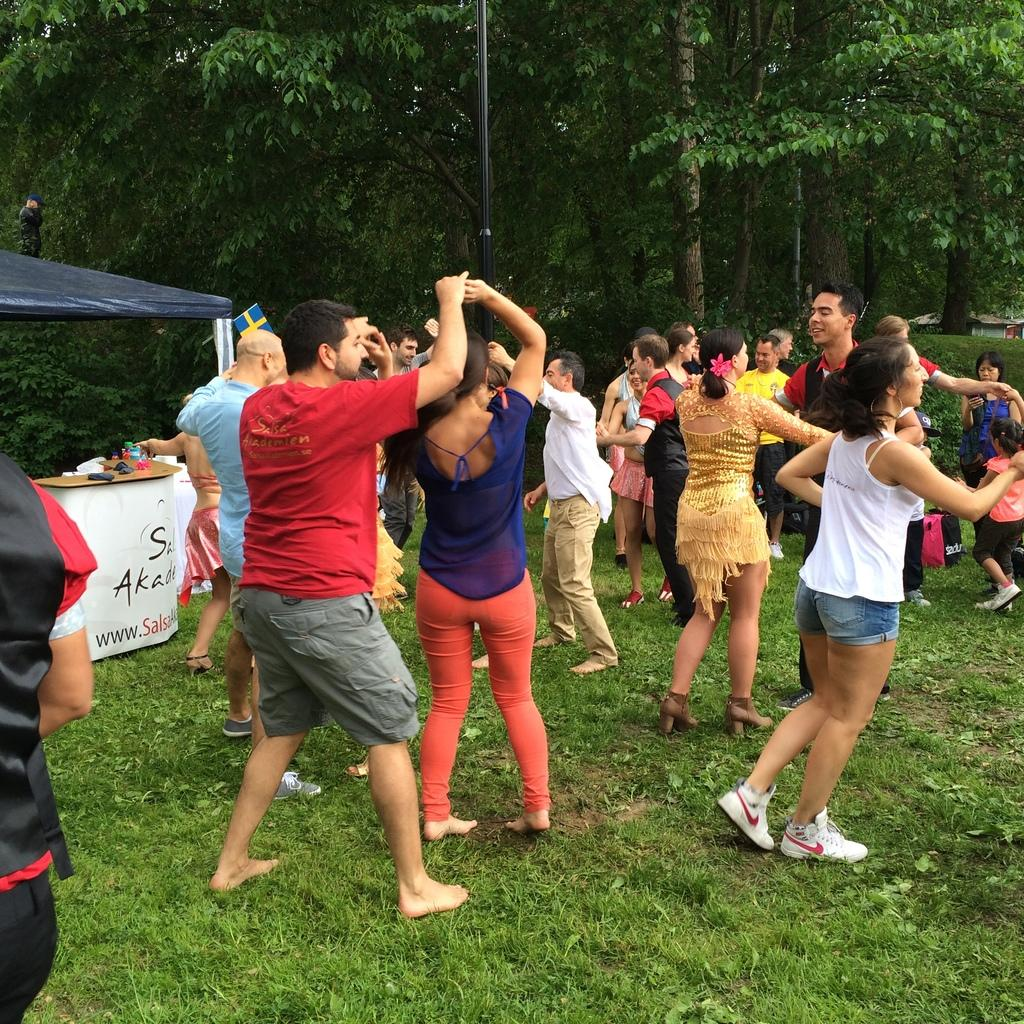What are the persons in the image doing? The persons in the image are dancing. What color is the ground they are dancing on? The ground they are dancing on is green. What can be seen in the left corner of the image? There is a table and other objects in the left corner of the image. What is visible in the background of the image? There are trees in the background of the image. Can you tell me how many horses are participating in the dance in the image? There are no horses present in the image; the persons are dancing without any horses. What type of motion is the playground equipment making in the image? There is no playground equipment present in the image, so it cannot be determined what type of motion it might be making. 